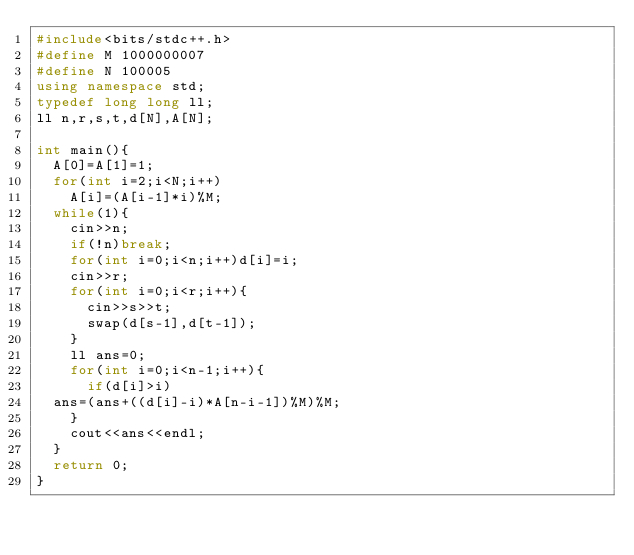<code> <loc_0><loc_0><loc_500><loc_500><_C++_>#include<bits/stdc++.h>
#define M 1000000007
#define N 100005
using namespace std;
typedef long long ll;
ll n,r,s,t,d[N],A[N];

int main(){
  A[0]=A[1]=1;
  for(int i=2;i<N;i++)
    A[i]=(A[i-1]*i)%M;
  while(1){
    cin>>n;
    if(!n)break;
    for(int i=0;i<n;i++)d[i]=i;
    cin>>r;
    for(int i=0;i<r;i++){
      cin>>s>>t;
      swap(d[s-1],d[t-1]);
    }
    ll ans=0;
    for(int i=0;i<n-1;i++){
      if(d[i]>i)
	ans=(ans+((d[i]-i)*A[n-i-1])%M)%M;
    }
    cout<<ans<<endl;
  }
  return 0;
}</code> 